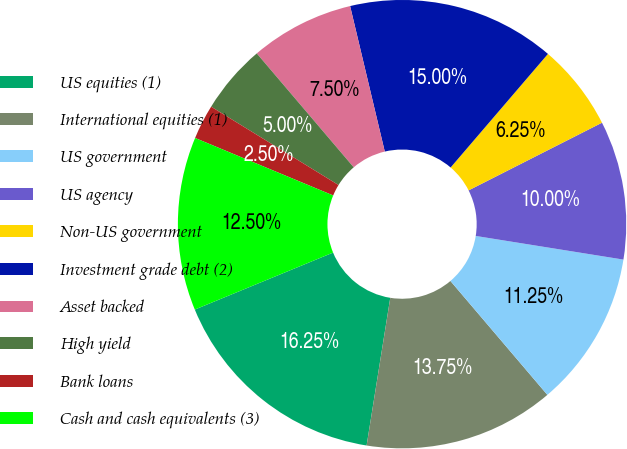Convert chart. <chart><loc_0><loc_0><loc_500><loc_500><pie_chart><fcel>US equities (1)<fcel>International equities (1)<fcel>US government<fcel>US agency<fcel>Non-US government<fcel>Investment grade debt (2)<fcel>Asset backed<fcel>High yield<fcel>Bank loans<fcel>Cash and cash equivalents (3)<nl><fcel>16.25%<fcel>13.75%<fcel>11.25%<fcel>10.0%<fcel>6.25%<fcel>15.0%<fcel>7.5%<fcel>5.0%<fcel>2.5%<fcel>12.5%<nl></chart> 